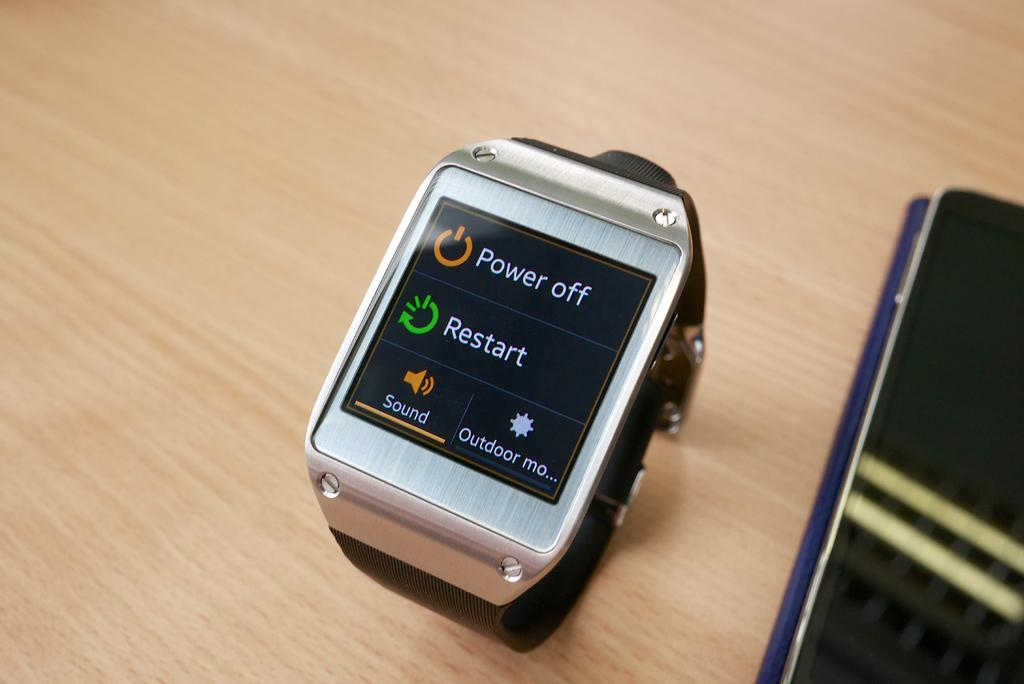Provide a one-sentence caption for the provided image. A watch screen's display has options to power off and restart. 